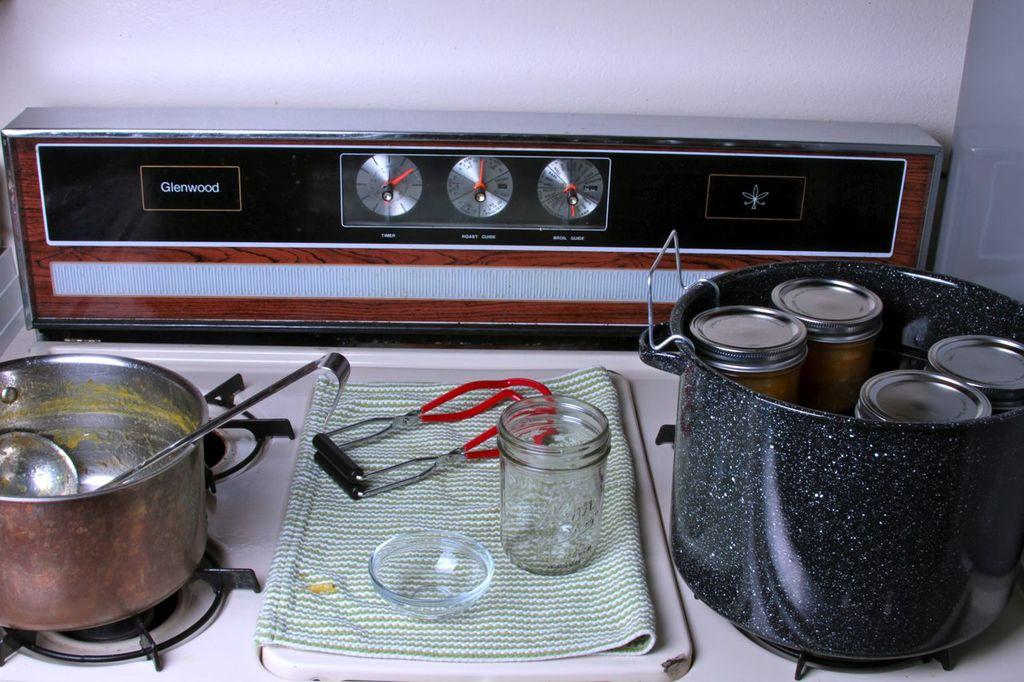<image>
Relay a brief, clear account of the picture shown. A canning supplies sit on the top of a Glenwood stove top. 